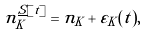Convert formula to latex. <formula><loc_0><loc_0><loc_500><loc_500>n _ { K } ^ { \underline { S } [ t ] } = n _ { K } + \varepsilon _ { K } ( t ) ,</formula> 